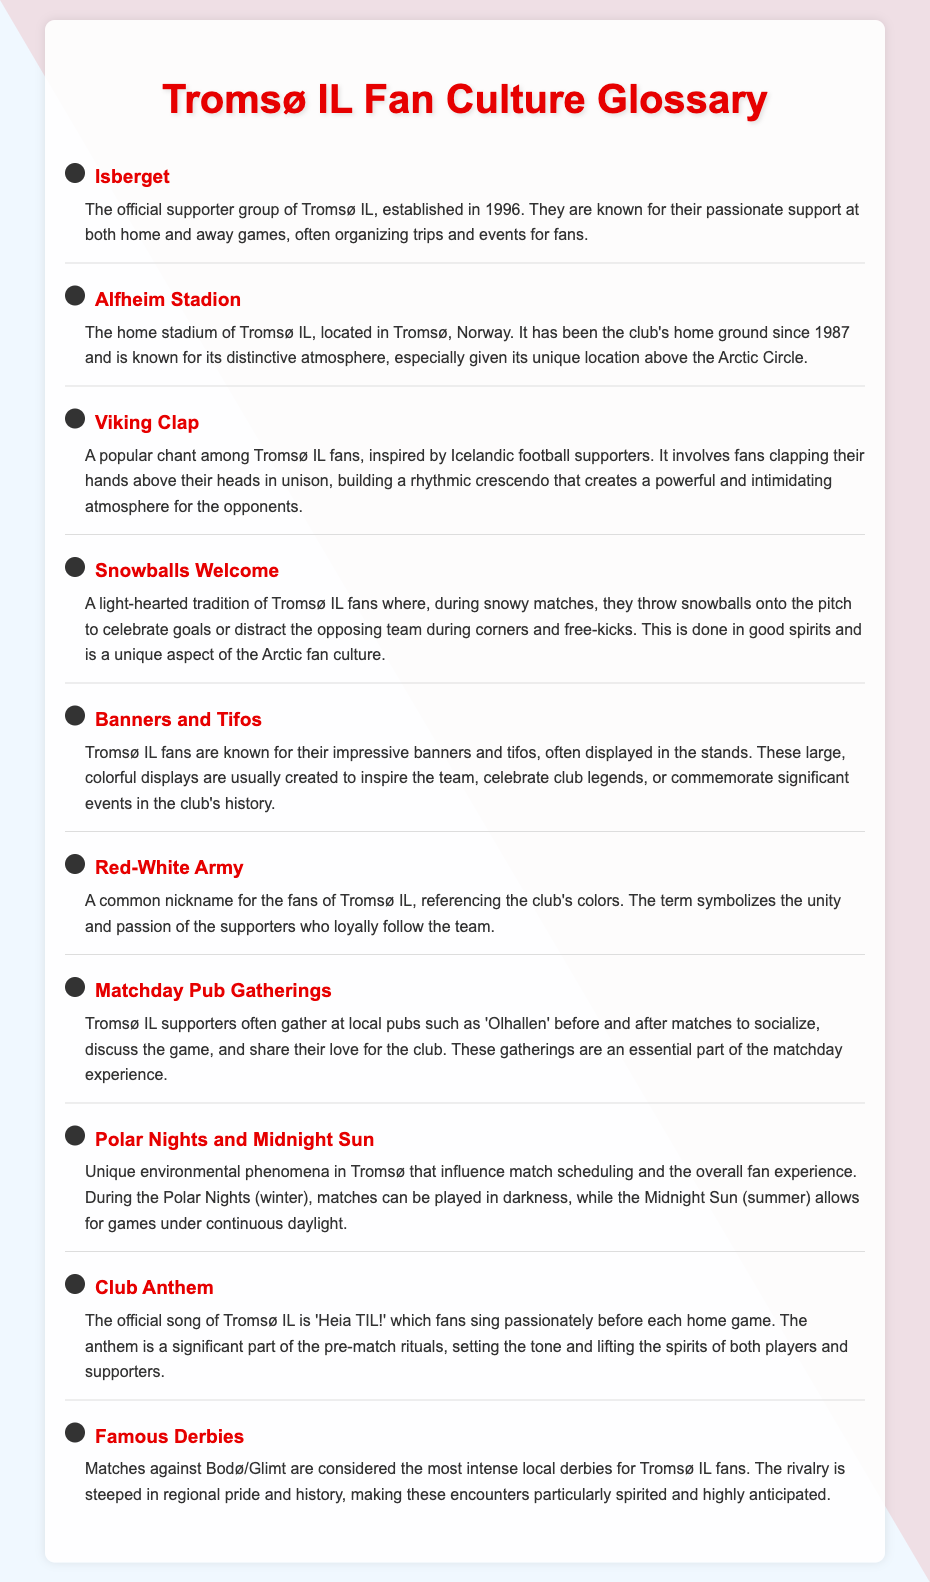What is the official supporter group of Tromsø IL? The official supporter group, established in 1996, is known for their passionate support at both home and away games.
Answer: Isberget What is the name of Tromsø IL's home stadium? The home stadium is known for its distinctive atmosphere, especially given its unique location above the Arctic Circle.
Answer: Alfheim Stadion What chant do Tromsø IL fans perform inspired by Icelandic football supporters? This popular chant involves fans clapping their hands above their heads in unison, creating a powerful atmosphere.
Answer: Viking Clap What tradition involves fans throwing snowballs during matches? This light-hearted tradition celebrates goals or distracts the opposing team during snowy matches.
Answer: Snowballs Welcome What is the official song of Tromsø IL? This song is sung passionately by fans before each home game, setting the tone for the match.
Answer: Heia TIL! What do Tromsø IL fans commonly gather for at local pubs before matches? Fans socialize, discuss the game, and share their love for the club during these gatherings.
Answer: Matchday Pub Gatherings Which matches are considered the most intense local derbies for Tromsø IL fans? The rivalry steeped in regional pride and history makes these encounters highly anticipated.
Answer: Bodø/Glimt What phenomenon influences match scheduling in Tromsø? These phenomena create unique challenges for fans and players throughout the year.
Answer: Polar Nights and Midnight Sun 